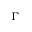<formula> <loc_0><loc_0><loc_500><loc_500>\Gamma</formula> 